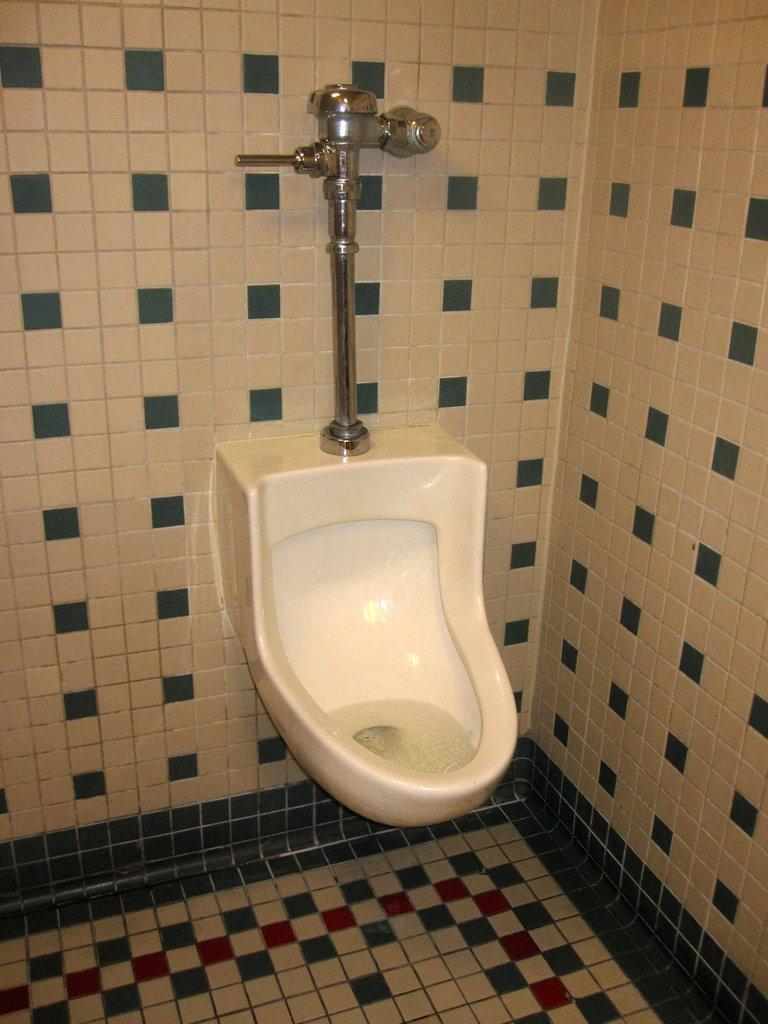What type of structure can be seen in the image? There are walls in the image, which suggests a structure of some kind. What is the surface beneath the walls in the image? There is a floor in the image. What specific object is present in the image? There is a toilet seat in the image. What type of club can be seen in the image? There is no club present in the image. How many pigs are visible in the image? There are no pigs present in the image. 